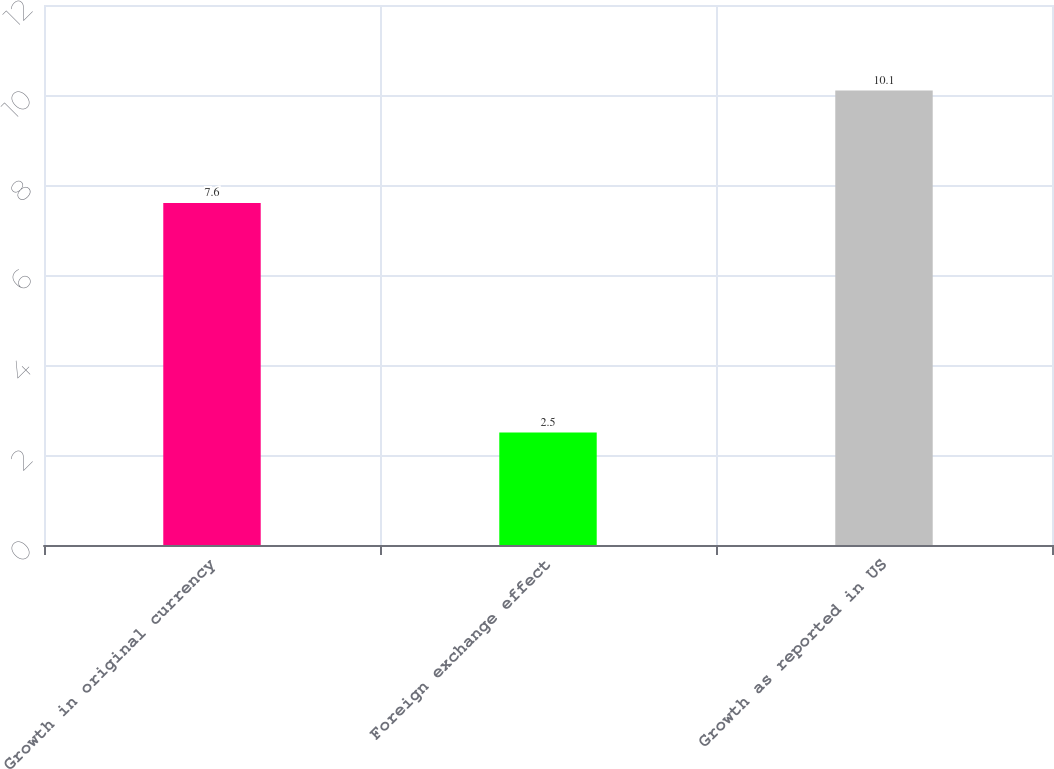<chart> <loc_0><loc_0><loc_500><loc_500><bar_chart><fcel>Growth in original currency<fcel>Foreign exchange effect<fcel>Growth as reported in US<nl><fcel>7.6<fcel>2.5<fcel>10.1<nl></chart> 